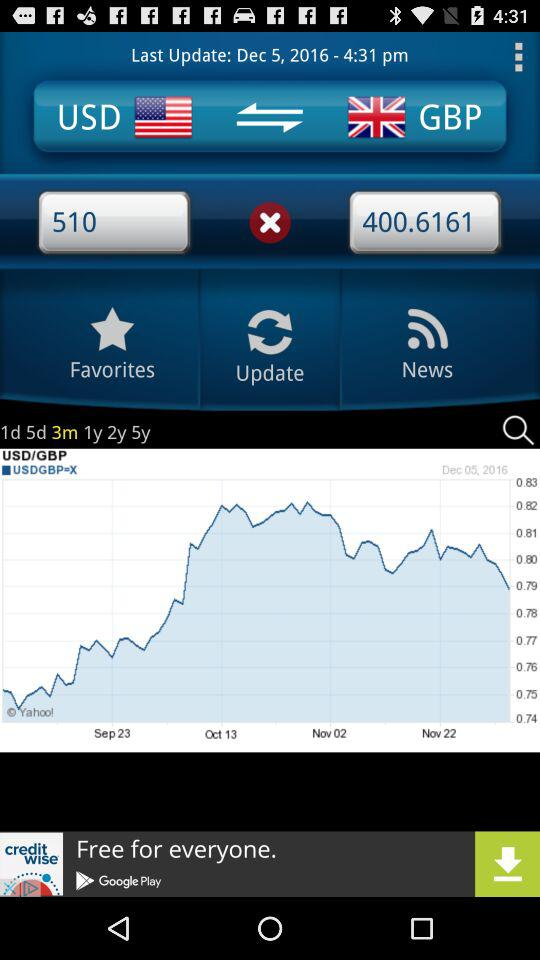What is the time? The time is 4:31 p.m. 